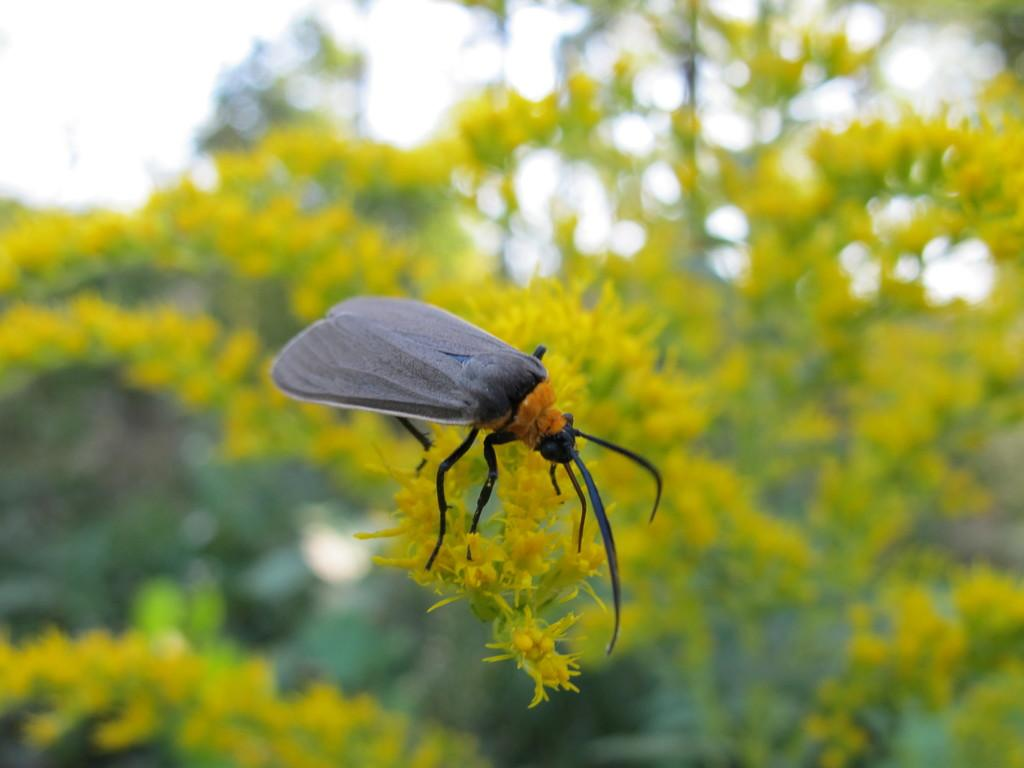What is present on the flowers in the image? There is an insect on the flowers in the image. What can be seen in the background of the image? There are trees visible in the background of the image. What type of berry can be seen growing on the volcano in the image? There is no volcano or berry present in the image; it features an insect on flowers with trees in the background. 